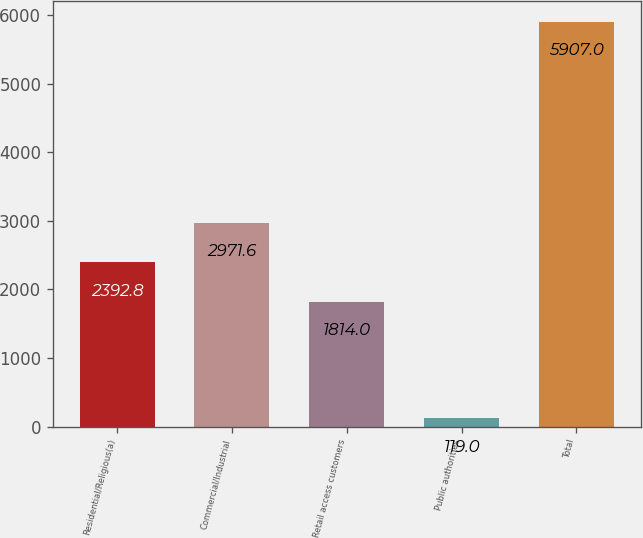Convert chart. <chart><loc_0><loc_0><loc_500><loc_500><bar_chart><fcel>Residential/Religious(a)<fcel>Commercial/Industrial<fcel>Retail access customers<fcel>Public authorities<fcel>Total<nl><fcel>2392.8<fcel>2971.6<fcel>1814<fcel>119<fcel>5907<nl></chart> 